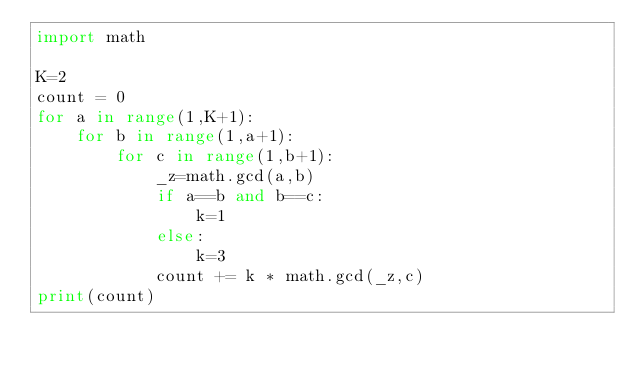Convert code to text. <code><loc_0><loc_0><loc_500><loc_500><_Python_>import math

K=2
count = 0
for a in range(1,K+1):
    for b in range(1,a+1):
        for c in range(1,b+1):
            _z=math.gcd(a,b)
            if a==b and b==c:
                k=1
            else:
                k=3
            count += k * math.gcd(_z,c)
print(count)</code> 